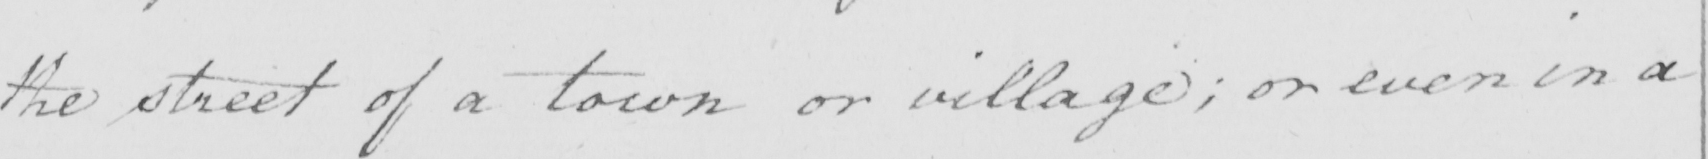Can you read and transcribe this handwriting? the street of a town or village ; or even in a 